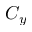<formula> <loc_0><loc_0><loc_500><loc_500>C _ { y }</formula> 